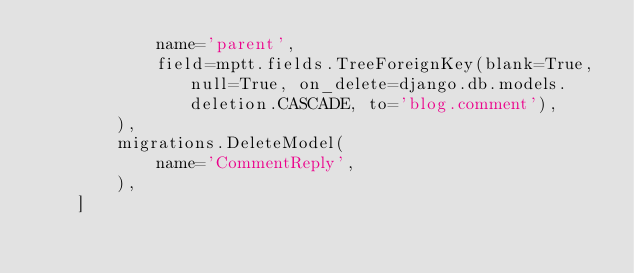<code> <loc_0><loc_0><loc_500><loc_500><_Python_>            name='parent',
            field=mptt.fields.TreeForeignKey(blank=True, null=True, on_delete=django.db.models.deletion.CASCADE, to='blog.comment'),
        ),
        migrations.DeleteModel(
            name='CommentReply',
        ),
    ]
</code> 